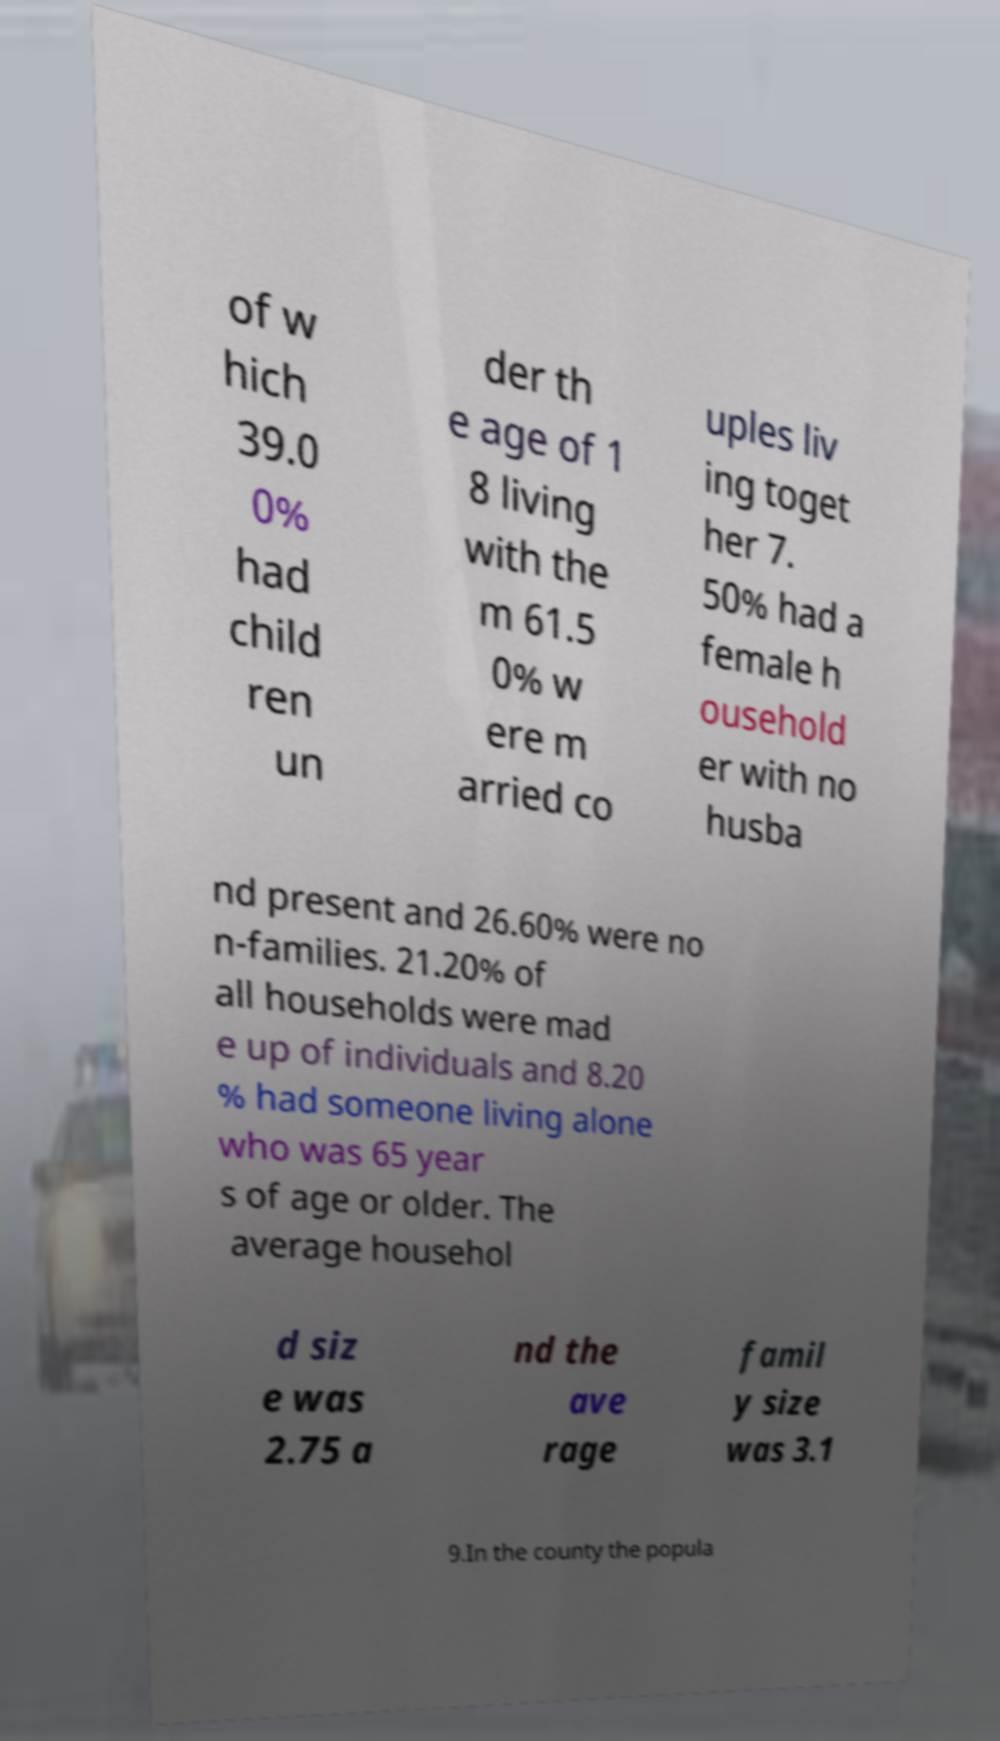Please identify and transcribe the text found in this image. of w hich 39.0 0% had child ren un der th e age of 1 8 living with the m 61.5 0% w ere m arried co uples liv ing toget her 7. 50% had a female h ousehold er with no husba nd present and 26.60% were no n-families. 21.20% of all households were mad e up of individuals and 8.20 % had someone living alone who was 65 year s of age or older. The average househol d siz e was 2.75 a nd the ave rage famil y size was 3.1 9.In the county the popula 